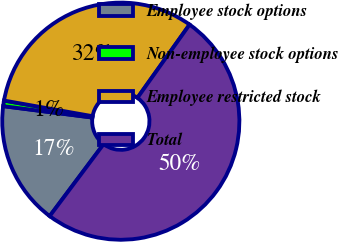<chart> <loc_0><loc_0><loc_500><loc_500><pie_chart><fcel>Employee stock options<fcel>Non-employee stock options<fcel>Employee restricted stock<fcel>Total<nl><fcel>16.79%<fcel>0.76%<fcel>32.06%<fcel>50.38%<nl></chart> 